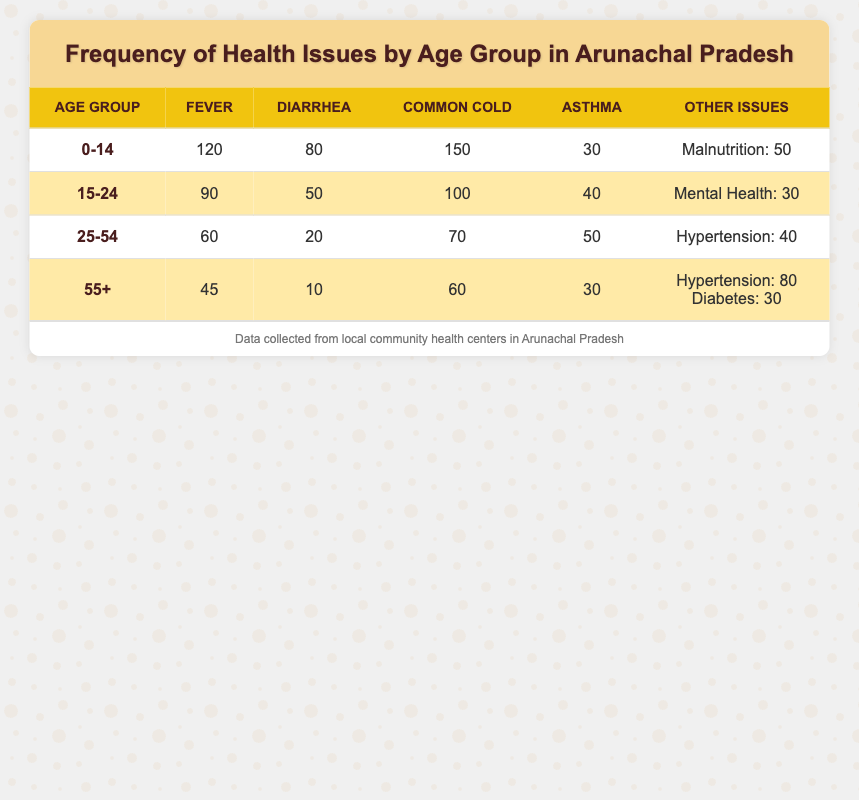What is the most commonly reported health issue in the age group 0-14? In the age group 0-14, the frequencies of health issues are: Fever (120), Diarrhea (80), Common Cold (150), Asthma (30), and Malnutrition (50). The highest value is for Common Cold at 150.
Answer: Common Cold Which age group has reported the least diarrhea cases? Looking at the table, we find: Age group 0-14 has 80 cases, age group 15-24 has 50 cases, age group 25-54 has 20 cases, and age group 55+ has 10 cases. The least is 10 cases in the 55+ age group.
Answer: 55+ Is the number of asthma cases higher in the age group 25-54 compared to 15-24? The asthma cases in age group 25-54 is 50, while in age group 15-24 it is 40. Since 50 is greater than 40, the answer is yes.
Answer: Yes What health issue has the highest total frequency across all age groups? To find the total for each health issue, we sum them up: Fever (120 + 90 + 60 + 45 = 315), Diarrhea (80 + 50 + 20 + 10 = 160), Common Cold (150 + 100 + 70 + 60 = 380), Asthma (30 + 40 + 50 + 30 = 150), and Malnutrition (50) and mental health (30) are unique to certain age groups and not counted across all. The highest total is 380 for Common Cold.
Answer: Common Cold Are there more cases of hypertension among those aged 55+ compared to those aged 25-54? Hypertension cases in age group 55+ are 80, while in age group 25-54 it is 40. 80 is greater than 40, so the answer is yes.
Answer: Yes What is the total number of health issues reported for the age group 15-24? We add up all the health issues in the age group 15-24: Fever (90) + Diarrhea (50) + Common Cold (100) + Asthma (40) + Mental Health (30) = 310 total health issues reported for this group.
Answer: 310 How many more cases of fever are reported in the age group 0-14 than in the age group 55+? Fever cases in age group 0-14 are 120, while in age group 55+ they are 45. To find the difference, we subtract 45 from 120: 120 - 45 = 75.
Answer: 75 What percentage of the 25-54 age group reported asthma issues? There are 50 asthma cases in the 25-54 age group (which is the only age range with asthma). The total number of reported health issues in this age group is 60 (Fever) + 20 (Diarrhea) + 70 (Common Cold) + 50 (Asthma) + 40 (Hypertension) = 240. To find the percentage of asthma cases, we calculate (50/240) * 100 = 20.83%.
Answer: 20.83% 